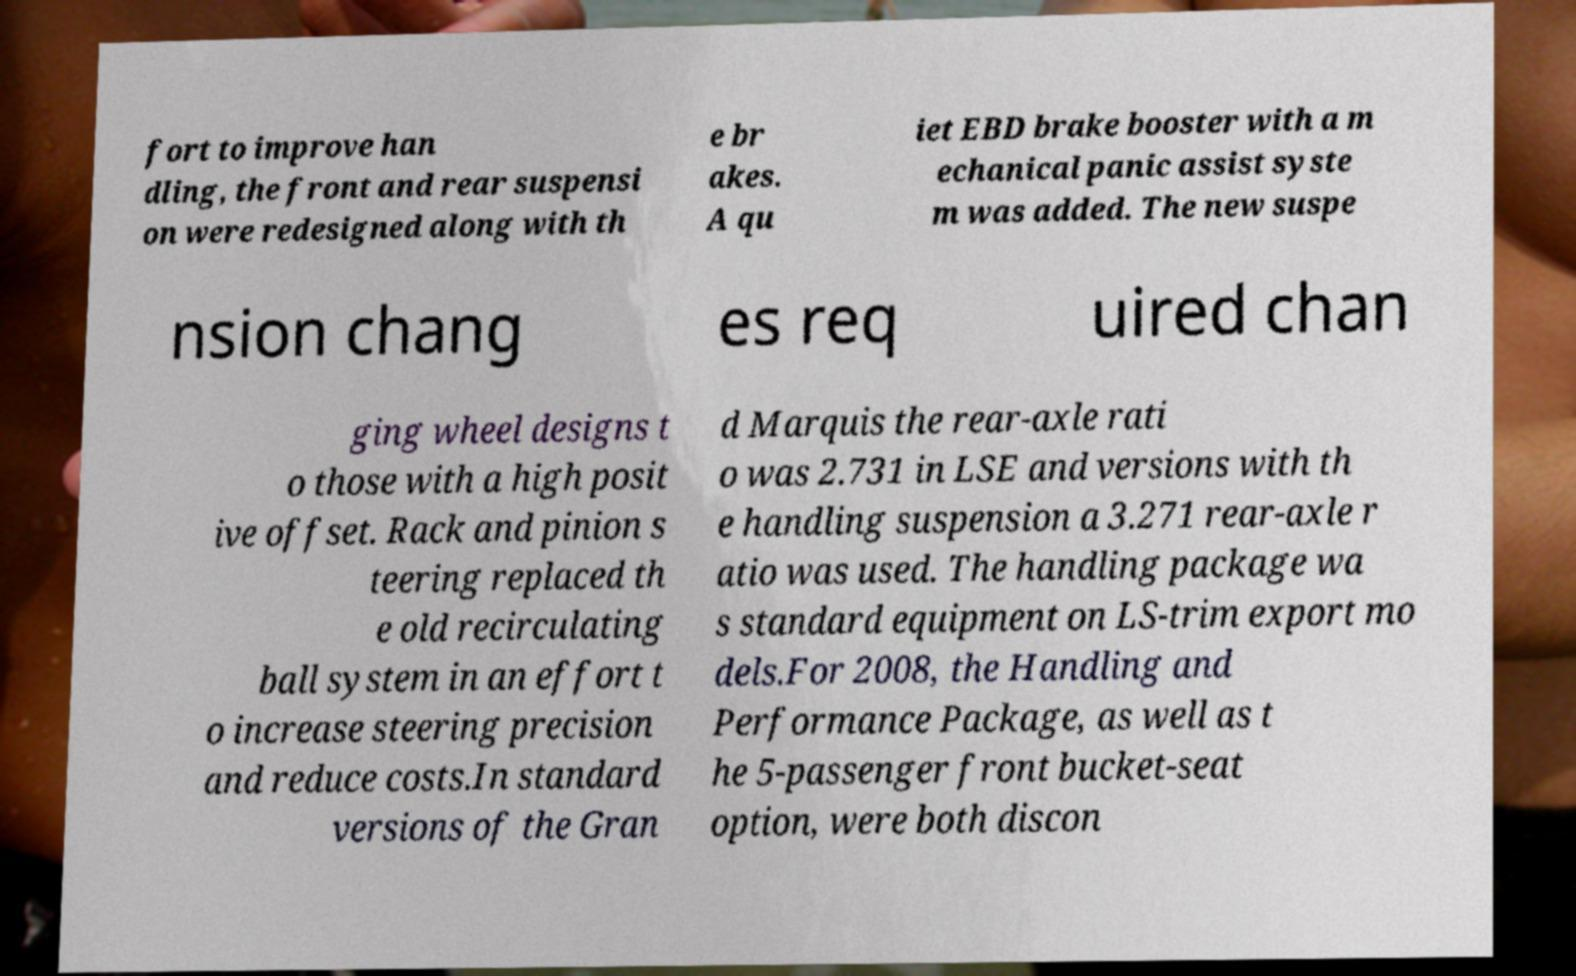Could you extract and type out the text from this image? fort to improve han dling, the front and rear suspensi on were redesigned along with th e br akes. A qu iet EBD brake booster with a m echanical panic assist syste m was added. The new suspe nsion chang es req uired chan ging wheel designs t o those with a high posit ive offset. Rack and pinion s teering replaced th e old recirculating ball system in an effort t o increase steering precision and reduce costs.In standard versions of the Gran d Marquis the rear-axle rati o was 2.731 in LSE and versions with th e handling suspension a 3.271 rear-axle r atio was used. The handling package wa s standard equipment on LS-trim export mo dels.For 2008, the Handling and Performance Package, as well as t he 5-passenger front bucket-seat option, were both discon 